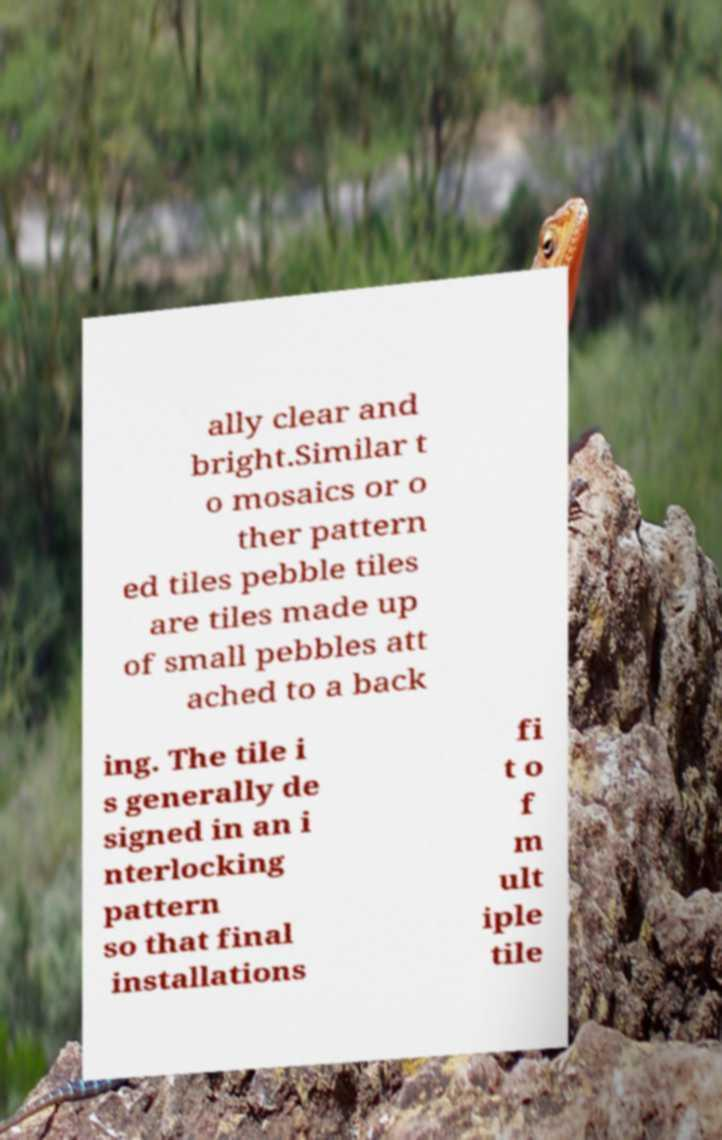Please read and relay the text visible in this image. What does it say? ally clear and bright.Similar t o mosaics or o ther pattern ed tiles pebble tiles are tiles made up of small pebbles att ached to a back ing. The tile i s generally de signed in an i nterlocking pattern so that final installations fi t o f m ult iple tile 